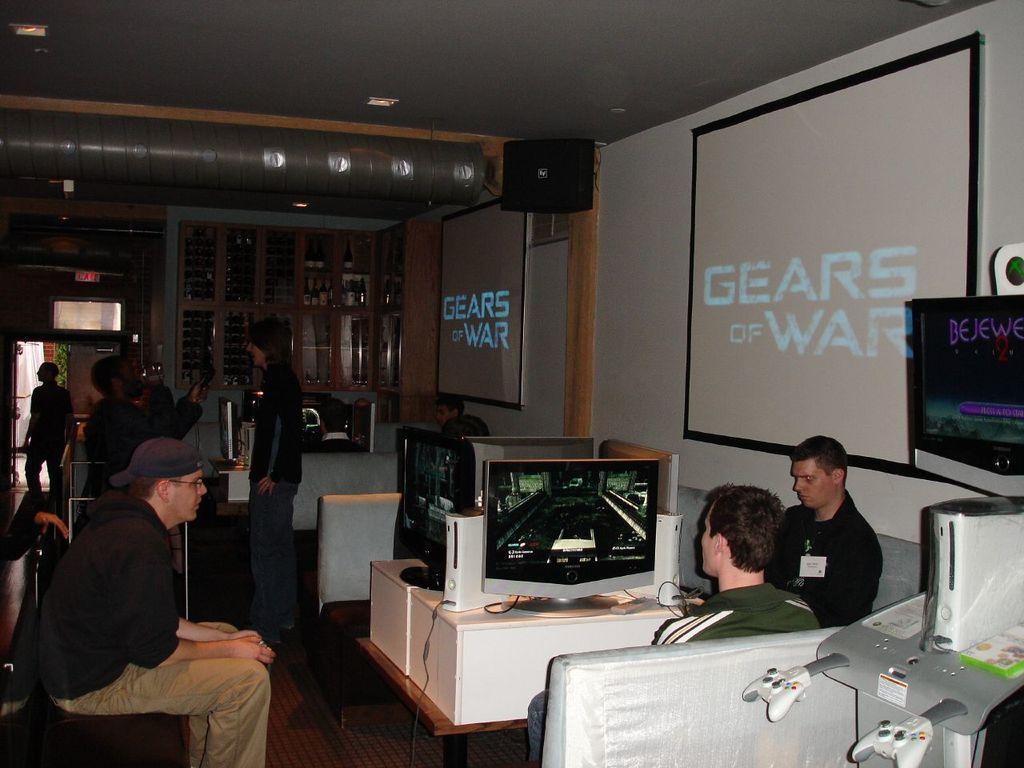In one or two sentences, can you explain what this image depicts? This picture is clicked inside. In the foreground we can see the group of persons sitting on the chairs and we can see the monitors and many electronic devices. On the right corner we can see the projector screens hanging on the wall. In the background we can see the group of persons, cabinets containing some items and some other objects. At the top there is a roof and we can see the ceiling lights, wall mounted speaker and some other objects. 